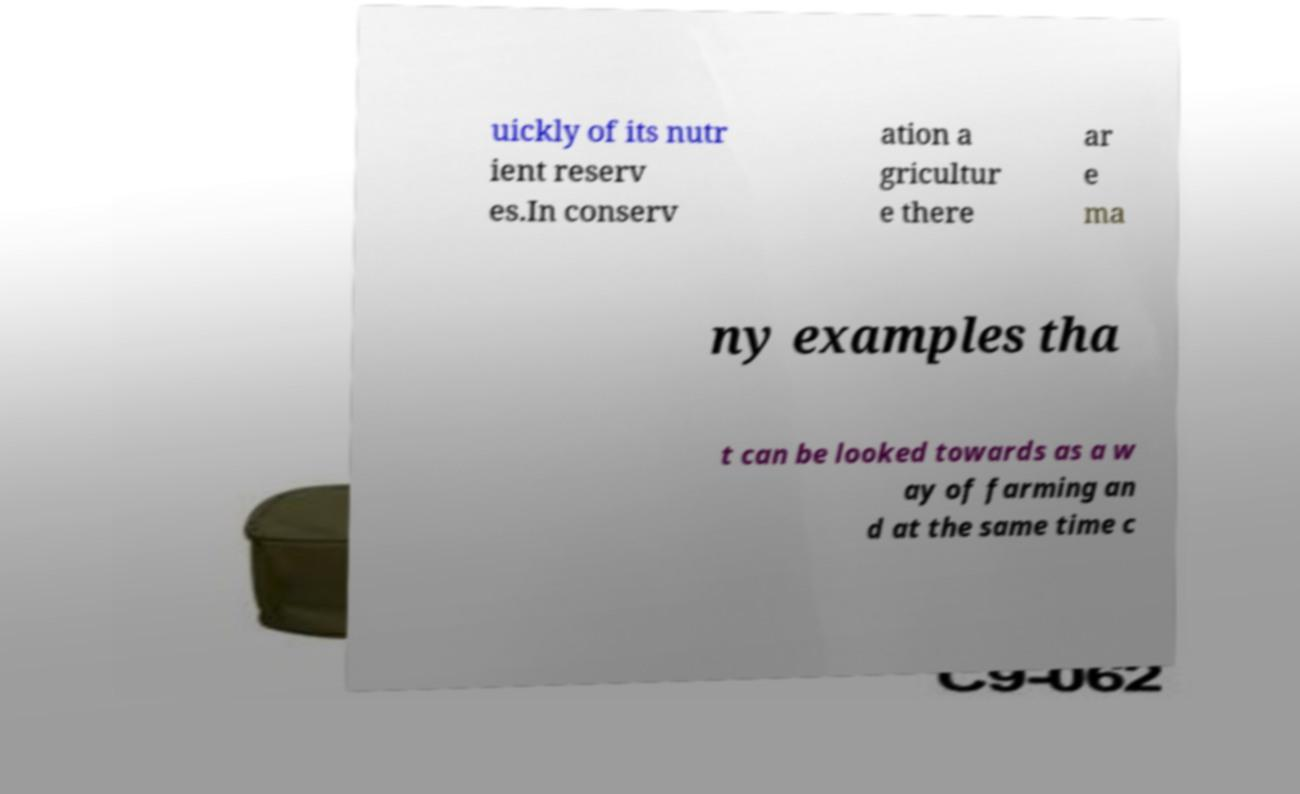For documentation purposes, I need the text within this image transcribed. Could you provide that? uickly of its nutr ient reserv es.In conserv ation a gricultur e there ar e ma ny examples tha t can be looked towards as a w ay of farming an d at the same time c 